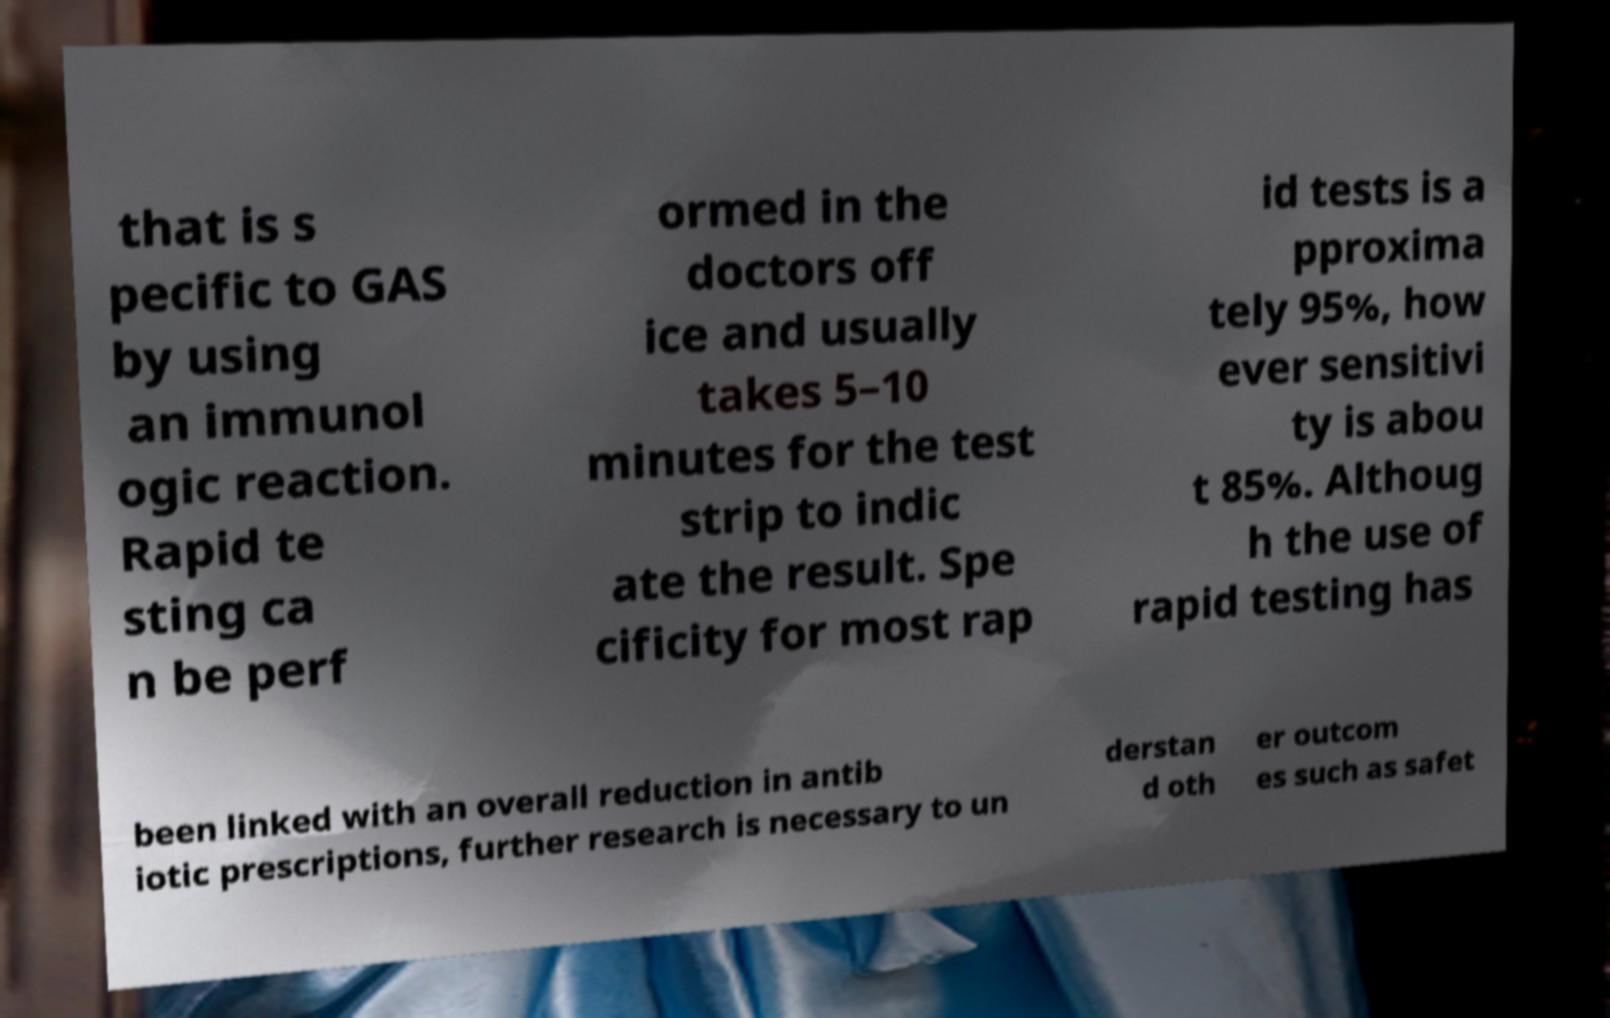For documentation purposes, I need the text within this image transcribed. Could you provide that? that is s pecific to GAS by using an immunol ogic reaction. Rapid te sting ca n be perf ormed in the doctors off ice and usually takes 5–10 minutes for the test strip to indic ate the result. Spe cificity for most rap id tests is a pproxima tely 95%, how ever sensitivi ty is abou t 85%. Althoug h the use of rapid testing has been linked with an overall reduction in antib iotic prescriptions, further research is necessary to un derstan d oth er outcom es such as safet 